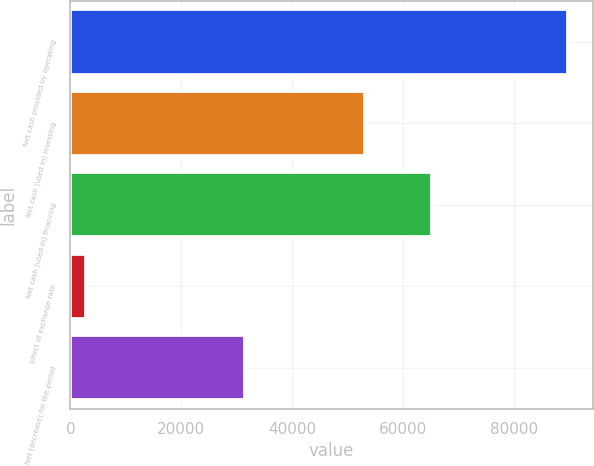Convert chart. <chart><loc_0><loc_0><loc_500><loc_500><bar_chart><fcel>Net cash provided by operating<fcel>Net cash (used in) investing<fcel>Net cash (used in) financing<fcel>Effect of exchange rate<fcel>Net (decrease) for the period<nl><fcel>89747<fcel>53180<fcel>65294<fcel>2758<fcel>31485<nl></chart> 